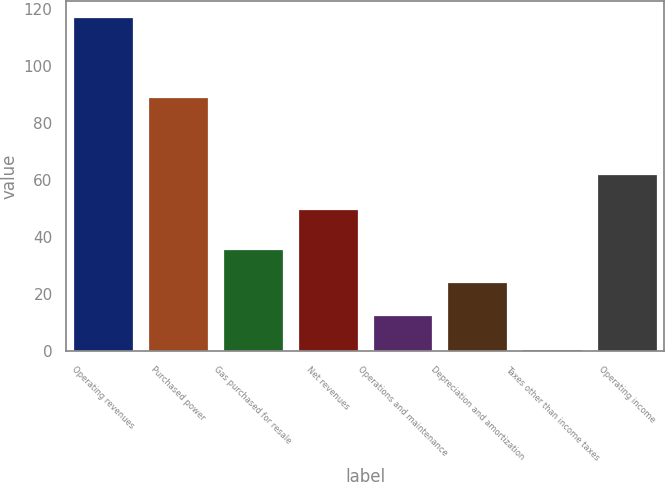Convert chart. <chart><loc_0><loc_0><loc_500><loc_500><bar_chart><fcel>Operating revenues<fcel>Purchased power<fcel>Gas purchased for resale<fcel>Net revenues<fcel>Operations and maintenance<fcel>Depreciation and amortization<fcel>Taxes other than income taxes<fcel>Operating income<nl><fcel>117<fcel>89<fcel>35.8<fcel>50<fcel>12.6<fcel>24.2<fcel>1<fcel>62<nl></chart> 